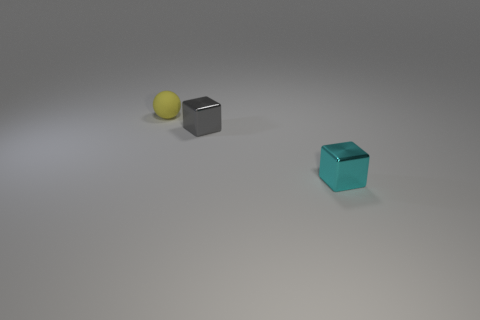Is there anything else that has the same material as the yellow thing?
Ensure brevity in your answer.  No. Is the number of gray shiny objects greater than the number of shiny blocks?
Your answer should be compact. No. There is a cube to the left of the small object right of the shiny block on the left side of the tiny cyan shiny cube; what is its color?
Provide a succinct answer. Gray. The other cube that is made of the same material as the tiny cyan block is what color?
Ensure brevity in your answer.  Gray. What number of objects are small things behind the small cyan metal cube or tiny things that are in front of the small sphere?
Your response must be concise. 3. Is the size of the block behind the cyan metallic cube the same as the thing behind the small gray metal cube?
Offer a very short reply. Yes. What is the color of the other object that is the same shape as the gray thing?
Ensure brevity in your answer.  Cyan. Is there any other thing that is the same shape as the tiny yellow object?
Provide a short and direct response. No. Are there more small cyan shiny cubes to the right of the small rubber object than small shiny things to the left of the gray shiny block?
Provide a short and direct response. Yes. Do the small cyan cube and the thing that is behind the gray metal object have the same material?
Give a very brief answer. No. 